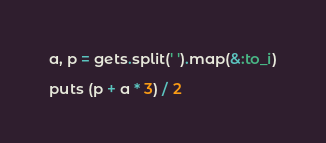Convert code to text. <code><loc_0><loc_0><loc_500><loc_500><_Ruby_>a, p = gets.split(' ').map(&:to_i)

puts (p + a * 3) / 2
</code> 